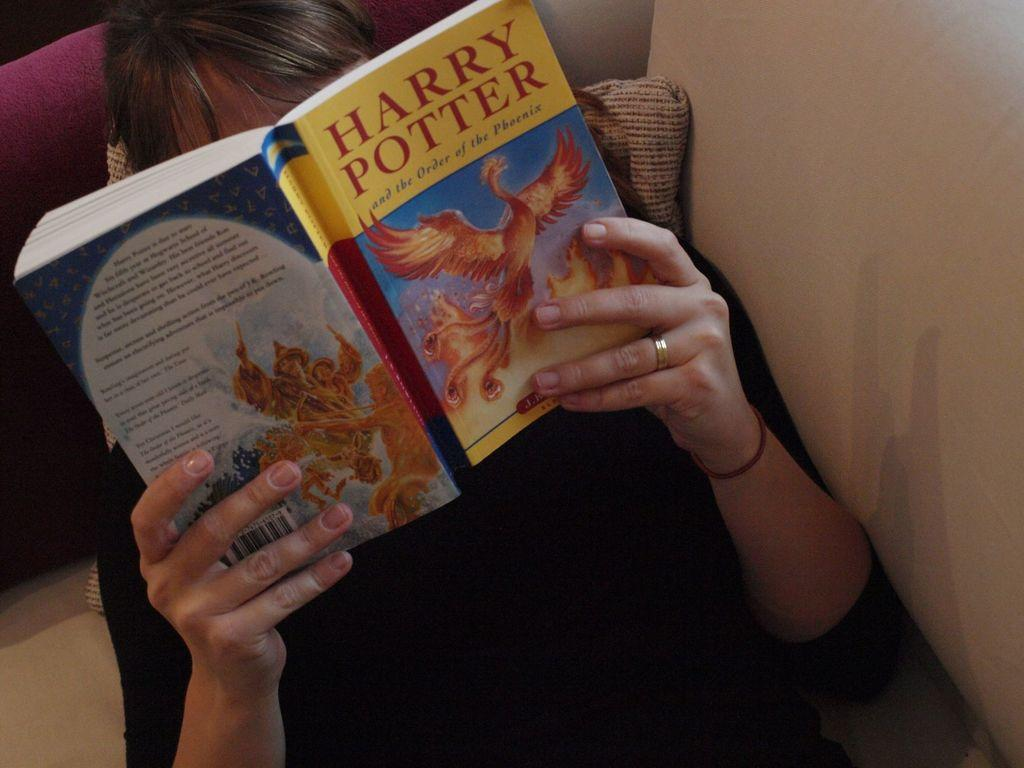<image>
Present a compact description of the photo's key features. A person is reading a harry potter book. 